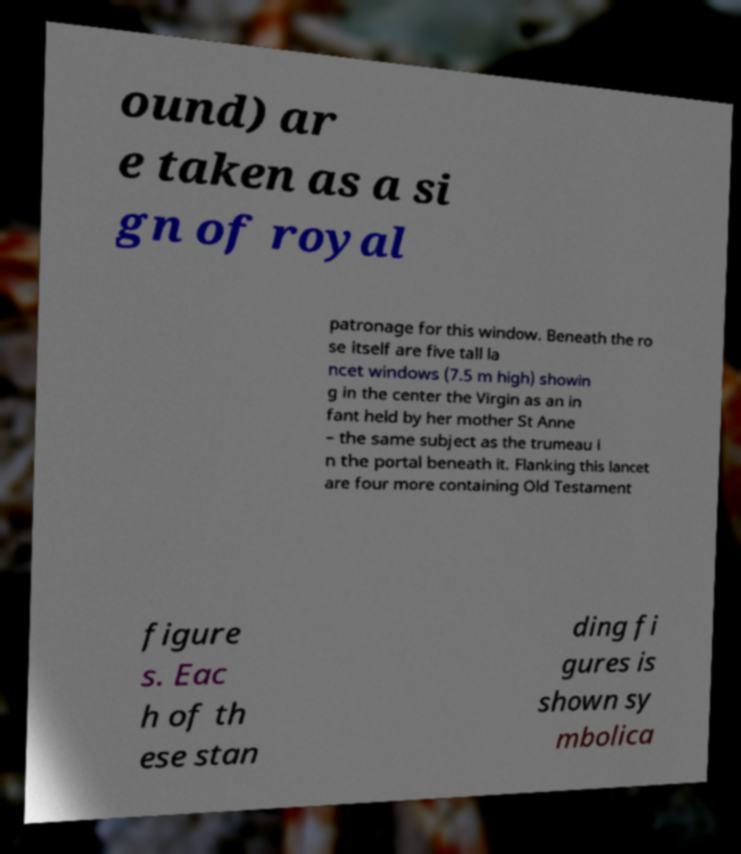Can you read and provide the text displayed in the image?This photo seems to have some interesting text. Can you extract and type it out for me? ound) ar e taken as a si gn of royal patronage for this window. Beneath the ro se itself are five tall la ncet windows (7.5 m high) showin g in the center the Virgin as an in fant held by her mother St Anne – the same subject as the trumeau i n the portal beneath it. Flanking this lancet are four more containing Old Testament figure s. Eac h of th ese stan ding fi gures is shown sy mbolica 